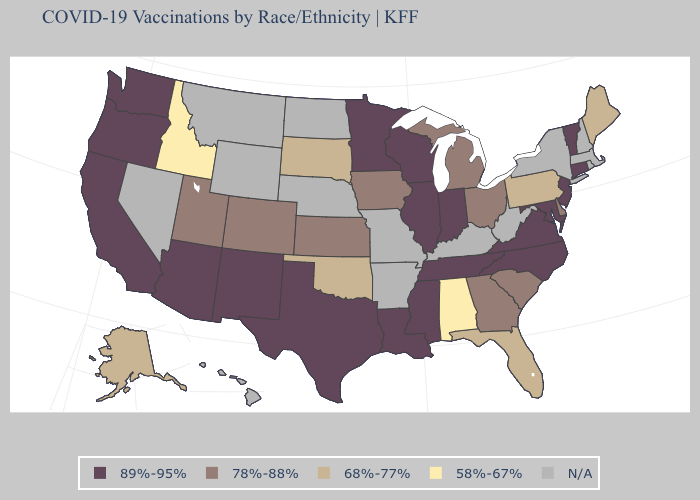Among the states that border Rhode Island , which have the highest value?
Short answer required. Connecticut. Does Alabama have the highest value in the South?
Answer briefly. No. Which states have the lowest value in the South?
Answer briefly. Alabama. Does the map have missing data?
Concise answer only. Yes. What is the highest value in the MidWest ?
Quick response, please. 89%-95%. Name the states that have a value in the range 78%-88%?
Answer briefly. Colorado, Delaware, Georgia, Iowa, Kansas, Michigan, Ohio, South Carolina, Utah. What is the highest value in the Northeast ?
Give a very brief answer. 89%-95%. What is the lowest value in the USA?
Short answer required. 58%-67%. How many symbols are there in the legend?
Concise answer only. 5. What is the lowest value in states that border Washington?
Give a very brief answer. 58%-67%. Does Maryland have the highest value in the South?
Quick response, please. Yes. Which states hav the highest value in the Northeast?
Answer briefly. Connecticut, New Jersey, Vermont. What is the lowest value in states that border New Hampshire?
Answer briefly. 68%-77%. Among the states that border Mississippi , which have the lowest value?
Be succinct. Alabama. What is the value of Minnesota?
Short answer required. 89%-95%. 